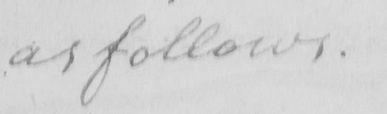Can you read and transcribe this handwriting? as follows . 